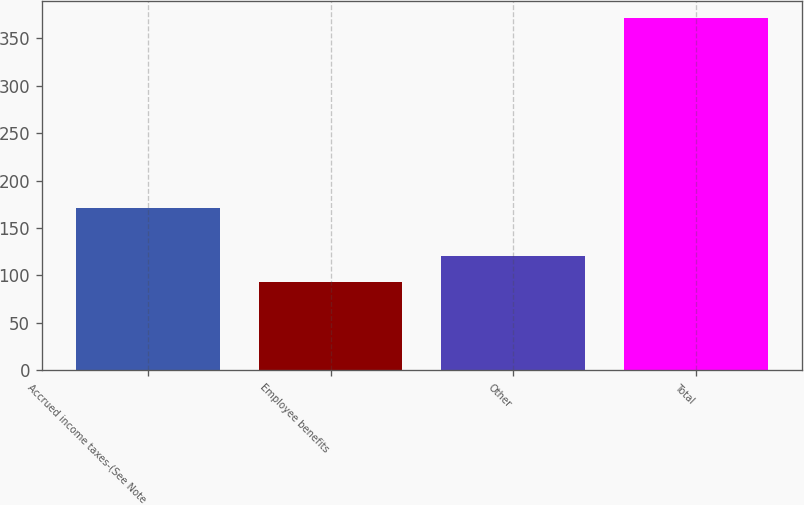Convert chart. <chart><loc_0><loc_0><loc_500><loc_500><bar_chart><fcel>Accrued income taxes-(See Note<fcel>Employee benefits<fcel>Other<fcel>Total<nl><fcel>171<fcel>93<fcel>120.8<fcel>371<nl></chart> 